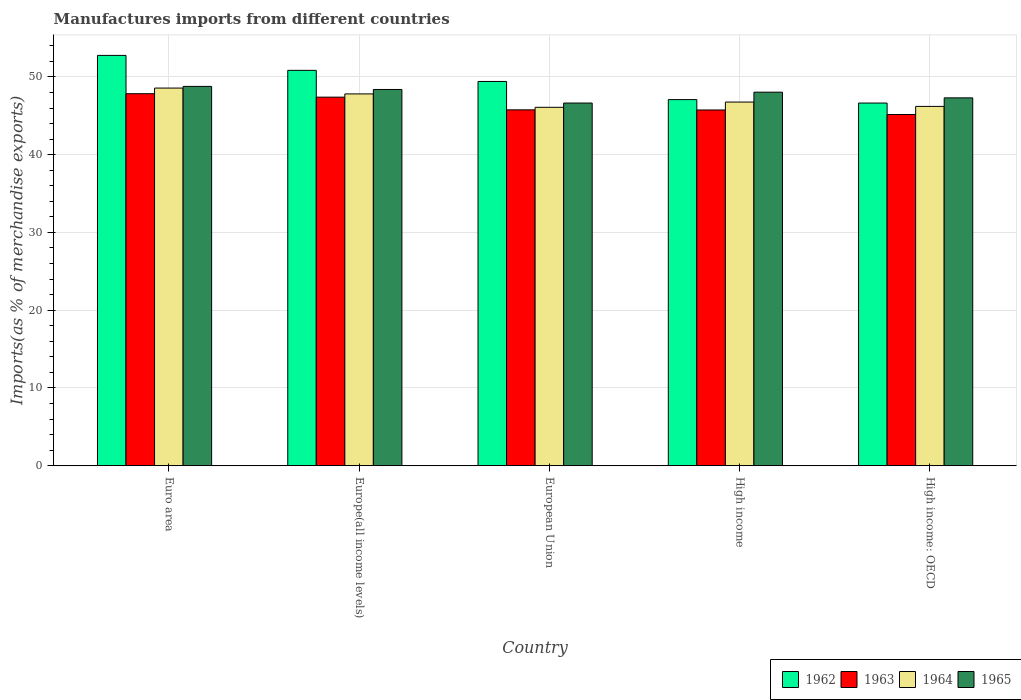How many groups of bars are there?
Your response must be concise. 5. Are the number of bars per tick equal to the number of legend labels?
Provide a short and direct response. Yes. Are the number of bars on each tick of the X-axis equal?
Offer a very short reply. Yes. How many bars are there on the 1st tick from the left?
Your answer should be very brief. 4. How many bars are there on the 5th tick from the right?
Keep it short and to the point. 4. What is the label of the 1st group of bars from the left?
Your response must be concise. Euro area. In how many cases, is the number of bars for a given country not equal to the number of legend labels?
Make the answer very short. 0. What is the percentage of imports to different countries in 1964 in High income: OECD?
Give a very brief answer. 46.21. Across all countries, what is the maximum percentage of imports to different countries in 1965?
Provide a succinct answer. 48.78. Across all countries, what is the minimum percentage of imports to different countries in 1962?
Make the answer very short. 46.64. In which country was the percentage of imports to different countries in 1962 minimum?
Ensure brevity in your answer.  High income: OECD. What is the total percentage of imports to different countries in 1963 in the graph?
Provide a short and direct response. 231.91. What is the difference between the percentage of imports to different countries in 1963 in Euro area and that in European Union?
Provide a succinct answer. 2.08. What is the difference between the percentage of imports to different countries in 1962 in High income and the percentage of imports to different countries in 1965 in Euro area?
Provide a succinct answer. -1.7. What is the average percentage of imports to different countries in 1963 per country?
Your response must be concise. 46.38. What is the difference between the percentage of imports to different countries of/in 1963 and percentage of imports to different countries of/in 1962 in High income: OECD?
Your answer should be very brief. -1.47. What is the ratio of the percentage of imports to different countries in 1963 in Euro area to that in High income?
Your answer should be compact. 1.05. Is the difference between the percentage of imports to different countries in 1963 in Euro area and Europe(all income levels) greater than the difference between the percentage of imports to different countries in 1962 in Euro area and Europe(all income levels)?
Offer a terse response. No. What is the difference between the highest and the second highest percentage of imports to different countries in 1964?
Provide a succinct answer. 1.8. What is the difference between the highest and the lowest percentage of imports to different countries in 1964?
Keep it short and to the point. 2.47. In how many countries, is the percentage of imports to different countries in 1962 greater than the average percentage of imports to different countries in 1962 taken over all countries?
Your answer should be compact. 3. Is the sum of the percentage of imports to different countries in 1962 in Euro area and High income: OECD greater than the maximum percentage of imports to different countries in 1963 across all countries?
Make the answer very short. Yes. Is it the case that in every country, the sum of the percentage of imports to different countries in 1964 and percentage of imports to different countries in 1965 is greater than the sum of percentage of imports to different countries in 1962 and percentage of imports to different countries in 1963?
Provide a succinct answer. No. Is it the case that in every country, the sum of the percentage of imports to different countries in 1963 and percentage of imports to different countries in 1962 is greater than the percentage of imports to different countries in 1964?
Keep it short and to the point. Yes. Are all the bars in the graph horizontal?
Offer a terse response. No. What is the difference between two consecutive major ticks on the Y-axis?
Provide a short and direct response. 10. Are the values on the major ticks of Y-axis written in scientific E-notation?
Offer a very short reply. No. Does the graph contain grids?
Provide a succinct answer. Yes. How many legend labels are there?
Provide a short and direct response. 4. How are the legend labels stacked?
Your answer should be very brief. Horizontal. What is the title of the graph?
Your answer should be compact. Manufactures imports from different countries. Does "1990" appear as one of the legend labels in the graph?
Your response must be concise. No. What is the label or title of the X-axis?
Offer a terse response. Country. What is the label or title of the Y-axis?
Ensure brevity in your answer.  Imports(as % of merchandise exports). What is the Imports(as % of merchandise exports) in 1962 in Euro area?
Give a very brief answer. 52.77. What is the Imports(as % of merchandise exports) in 1963 in Euro area?
Give a very brief answer. 47.84. What is the Imports(as % of merchandise exports) in 1964 in Euro area?
Offer a very short reply. 48.56. What is the Imports(as % of merchandise exports) in 1965 in Euro area?
Your answer should be compact. 48.78. What is the Imports(as % of merchandise exports) in 1962 in Europe(all income levels)?
Offer a very short reply. 50.84. What is the Imports(as % of merchandise exports) in 1963 in Europe(all income levels)?
Provide a short and direct response. 47.4. What is the Imports(as % of merchandise exports) of 1964 in Europe(all income levels)?
Provide a succinct answer. 47.81. What is the Imports(as % of merchandise exports) in 1965 in Europe(all income levels)?
Offer a very short reply. 48.38. What is the Imports(as % of merchandise exports) of 1962 in European Union?
Provide a succinct answer. 49.41. What is the Imports(as % of merchandise exports) in 1963 in European Union?
Make the answer very short. 45.76. What is the Imports(as % of merchandise exports) of 1964 in European Union?
Ensure brevity in your answer.  46.09. What is the Imports(as % of merchandise exports) in 1965 in European Union?
Provide a succinct answer. 46.64. What is the Imports(as % of merchandise exports) in 1962 in High income?
Offer a terse response. 47.08. What is the Imports(as % of merchandise exports) in 1963 in High income?
Offer a very short reply. 45.75. What is the Imports(as % of merchandise exports) in 1964 in High income?
Your answer should be very brief. 46.77. What is the Imports(as % of merchandise exports) in 1965 in High income?
Your answer should be very brief. 48.04. What is the Imports(as % of merchandise exports) in 1962 in High income: OECD?
Provide a succinct answer. 46.64. What is the Imports(as % of merchandise exports) in 1963 in High income: OECD?
Offer a terse response. 45.16. What is the Imports(as % of merchandise exports) in 1964 in High income: OECD?
Provide a succinct answer. 46.21. What is the Imports(as % of merchandise exports) in 1965 in High income: OECD?
Give a very brief answer. 47.3. Across all countries, what is the maximum Imports(as % of merchandise exports) in 1962?
Your answer should be very brief. 52.77. Across all countries, what is the maximum Imports(as % of merchandise exports) of 1963?
Provide a short and direct response. 47.84. Across all countries, what is the maximum Imports(as % of merchandise exports) in 1964?
Offer a very short reply. 48.56. Across all countries, what is the maximum Imports(as % of merchandise exports) in 1965?
Your answer should be compact. 48.78. Across all countries, what is the minimum Imports(as % of merchandise exports) in 1962?
Offer a very short reply. 46.64. Across all countries, what is the minimum Imports(as % of merchandise exports) of 1963?
Offer a terse response. 45.16. Across all countries, what is the minimum Imports(as % of merchandise exports) of 1964?
Make the answer very short. 46.09. Across all countries, what is the minimum Imports(as % of merchandise exports) of 1965?
Make the answer very short. 46.64. What is the total Imports(as % of merchandise exports) of 1962 in the graph?
Your response must be concise. 246.74. What is the total Imports(as % of merchandise exports) of 1963 in the graph?
Provide a succinct answer. 231.91. What is the total Imports(as % of merchandise exports) of 1964 in the graph?
Give a very brief answer. 235.44. What is the total Imports(as % of merchandise exports) in 1965 in the graph?
Give a very brief answer. 239.14. What is the difference between the Imports(as % of merchandise exports) of 1962 in Euro area and that in Europe(all income levels)?
Your answer should be very brief. 1.92. What is the difference between the Imports(as % of merchandise exports) in 1963 in Euro area and that in Europe(all income levels)?
Your answer should be very brief. 0.44. What is the difference between the Imports(as % of merchandise exports) in 1964 in Euro area and that in Europe(all income levels)?
Provide a succinct answer. 0.75. What is the difference between the Imports(as % of merchandise exports) of 1965 in Euro area and that in Europe(all income levels)?
Make the answer very short. 0.4. What is the difference between the Imports(as % of merchandise exports) in 1962 in Euro area and that in European Union?
Provide a short and direct response. 3.35. What is the difference between the Imports(as % of merchandise exports) in 1963 in Euro area and that in European Union?
Provide a succinct answer. 2.08. What is the difference between the Imports(as % of merchandise exports) in 1964 in Euro area and that in European Union?
Ensure brevity in your answer.  2.47. What is the difference between the Imports(as % of merchandise exports) of 1965 in Euro area and that in European Union?
Your answer should be compact. 2.14. What is the difference between the Imports(as % of merchandise exports) of 1962 in Euro area and that in High income?
Offer a terse response. 5.69. What is the difference between the Imports(as % of merchandise exports) of 1963 in Euro area and that in High income?
Give a very brief answer. 2.09. What is the difference between the Imports(as % of merchandise exports) of 1964 in Euro area and that in High income?
Offer a terse response. 1.8. What is the difference between the Imports(as % of merchandise exports) in 1965 in Euro area and that in High income?
Ensure brevity in your answer.  0.74. What is the difference between the Imports(as % of merchandise exports) of 1962 in Euro area and that in High income: OECD?
Keep it short and to the point. 6.13. What is the difference between the Imports(as % of merchandise exports) of 1963 in Euro area and that in High income: OECD?
Provide a short and direct response. 2.67. What is the difference between the Imports(as % of merchandise exports) in 1964 in Euro area and that in High income: OECD?
Ensure brevity in your answer.  2.36. What is the difference between the Imports(as % of merchandise exports) in 1965 in Euro area and that in High income: OECD?
Offer a very short reply. 1.47. What is the difference between the Imports(as % of merchandise exports) in 1962 in Europe(all income levels) and that in European Union?
Your answer should be very brief. 1.43. What is the difference between the Imports(as % of merchandise exports) in 1963 in Europe(all income levels) and that in European Union?
Give a very brief answer. 1.63. What is the difference between the Imports(as % of merchandise exports) of 1964 in Europe(all income levels) and that in European Union?
Provide a succinct answer. 1.72. What is the difference between the Imports(as % of merchandise exports) of 1965 in Europe(all income levels) and that in European Union?
Your answer should be very brief. 1.74. What is the difference between the Imports(as % of merchandise exports) of 1962 in Europe(all income levels) and that in High income?
Offer a very short reply. 3.76. What is the difference between the Imports(as % of merchandise exports) in 1963 in Europe(all income levels) and that in High income?
Your response must be concise. 1.65. What is the difference between the Imports(as % of merchandise exports) in 1964 in Europe(all income levels) and that in High income?
Your answer should be compact. 1.05. What is the difference between the Imports(as % of merchandise exports) in 1965 in Europe(all income levels) and that in High income?
Your answer should be very brief. 0.35. What is the difference between the Imports(as % of merchandise exports) in 1962 in Europe(all income levels) and that in High income: OECD?
Provide a succinct answer. 4.21. What is the difference between the Imports(as % of merchandise exports) of 1963 in Europe(all income levels) and that in High income: OECD?
Your response must be concise. 2.23. What is the difference between the Imports(as % of merchandise exports) of 1964 in Europe(all income levels) and that in High income: OECD?
Give a very brief answer. 1.61. What is the difference between the Imports(as % of merchandise exports) of 1965 in Europe(all income levels) and that in High income: OECD?
Provide a short and direct response. 1.08. What is the difference between the Imports(as % of merchandise exports) of 1962 in European Union and that in High income?
Give a very brief answer. 2.33. What is the difference between the Imports(as % of merchandise exports) in 1963 in European Union and that in High income?
Keep it short and to the point. 0.02. What is the difference between the Imports(as % of merchandise exports) in 1964 in European Union and that in High income?
Give a very brief answer. -0.68. What is the difference between the Imports(as % of merchandise exports) of 1965 in European Union and that in High income?
Your answer should be very brief. -1.4. What is the difference between the Imports(as % of merchandise exports) of 1962 in European Union and that in High income: OECD?
Ensure brevity in your answer.  2.78. What is the difference between the Imports(as % of merchandise exports) in 1963 in European Union and that in High income: OECD?
Keep it short and to the point. 0.6. What is the difference between the Imports(as % of merchandise exports) of 1964 in European Union and that in High income: OECD?
Give a very brief answer. -0.12. What is the difference between the Imports(as % of merchandise exports) of 1965 in European Union and that in High income: OECD?
Ensure brevity in your answer.  -0.67. What is the difference between the Imports(as % of merchandise exports) of 1962 in High income and that in High income: OECD?
Your response must be concise. 0.44. What is the difference between the Imports(as % of merchandise exports) of 1963 in High income and that in High income: OECD?
Offer a terse response. 0.58. What is the difference between the Imports(as % of merchandise exports) of 1964 in High income and that in High income: OECD?
Provide a succinct answer. 0.56. What is the difference between the Imports(as % of merchandise exports) of 1965 in High income and that in High income: OECD?
Make the answer very short. 0.73. What is the difference between the Imports(as % of merchandise exports) in 1962 in Euro area and the Imports(as % of merchandise exports) in 1963 in Europe(all income levels)?
Offer a terse response. 5.37. What is the difference between the Imports(as % of merchandise exports) in 1962 in Euro area and the Imports(as % of merchandise exports) in 1964 in Europe(all income levels)?
Ensure brevity in your answer.  4.95. What is the difference between the Imports(as % of merchandise exports) of 1962 in Euro area and the Imports(as % of merchandise exports) of 1965 in Europe(all income levels)?
Offer a terse response. 4.38. What is the difference between the Imports(as % of merchandise exports) in 1963 in Euro area and the Imports(as % of merchandise exports) in 1964 in Europe(all income levels)?
Offer a very short reply. 0.02. What is the difference between the Imports(as % of merchandise exports) of 1963 in Euro area and the Imports(as % of merchandise exports) of 1965 in Europe(all income levels)?
Provide a short and direct response. -0.54. What is the difference between the Imports(as % of merchandise exports) in 1964 in Euro area and the Imports(as % of merchandise exports) in 1965 in Europe(all income levels)?
Provide a succinct answer. 0.18. What is the difference between the Imports(as % of merchandise exports) of 1962 in Euro area and the Imports(as % of merchandise exports) of 1963 in European Union?
Your response must be concise. 7. What is the difference between the Imports(as % of merchandise exports) in 1962 in Euro area and the Imports(as % of merchandise exports) in 1964 in European Union?
Give a very brief answer. 6.68. What is the difference between the Imports(as % of merchandise exports) in 1962 in Euro area and the Imports(as % of merchandise exports) in 1965 in European Union?
Your answer should be compact. 6.13. What is the difference between the Imports(as % of merchandise exports) in 1963 in Euro area and the Imports(as % of merchandise exports) in 1964 in European Union?
Your response must be concise. 1.75. What is the difference between the Imports(as % of merchandise exports) in 1963 in Euro area and the Imports(as % of merchandise exports) in 1965 in European Union?
Offer a very short reply. 1.2. What is the difference between the Imports(as % of merchandise exports) in 1964 in Euro area and the Imports(as % of merchandise exports) in 1965 in European Union?
Give a very brief answer. 1.93. What is the difference between the Imports(as % of merchandise exports) of 1962 in Euro area and the Imports(as % of merchandise exports) of 1963 in High income?
Offer a very short reply. 7.02. What is the difference between the Imports(as % of merchandise exports) of 1962 in Euro area and the Imports(as % of merchandise exports) of 1964 in High income?
Ensure brevity in your answer.  6. What is the difference between the Imports(as % of merchandise exports) in 1962 in Euro area and the Imports(as % of merchandise exports) in 1965 in High income?
Keep it short and to the point. 4.73. What is the difference between the Imports(as % of merchandise exports) in 1963 in Euro area and the Imports(as % of merchandise exports) in 1964 in High income?
Offer a very short reply. 1.07. What is the difference between the Imports(as % of merchandise exports) of 1963 in Euro area and the Imports(as % of merchandise exports) of 1965 in High income?
Offer a very short reply. -0.2. What is the difference between the Imports(as % of merchandise exports) of 1964 in Euro area and the Imports(as % of merchandise exports) of 1965 in High income?
Your answer should be compact. 0.53. What is the difference between the Imports(as % of merchandise exports) of 1962 in Euro area and the Imports(as % of merchandise exports) of 1963 in High income: OECD?
Keep it short and to the point. 7.6. What is the difference between the Imports(as % of merchandise exports) of 1962 in Euro area and the Imports(as % of merchandise exports) of 1964 in High income: OECD?
Offer a very short reply. 6.56. What is the difference between the Imports(as % of merchandise exports) in 1962 in Euro area and the Imports(as % of merchandise exports) in 1965 in High income: OECD?
Offer a very short reply. 5.46. What is the difference between the Imports(as % of merchandise exports) in 1963 in Euro area and the Imports(as % of merchandise exports) in 1964 in High income: OECD?
Your response must be concise. 1.63. What is the difference between the Imports(as % of merchandise exports) in 1963 in Euro area and the Imports(as % of merchandise exports) in 1965 in High income: OECD?
Keep it short and to the point. 0.53. What is the difference between the Imports(as % of merchandise exports) of 1964 in Euro area and the Imports(as % of merchandise exports) of 1965 in High income: OECD?
Provide a succinct answer. 1.26. What is the difference between the Imports(as % of merchandise exports) in 1962 in Europe(all income levels) and the Imports(as % of merchandise exports) in 1963 in European Union?
Your response must be concise. 5.08. What is the difference between the Imports(as % of merchandise exports) of 1962 in Europe(all income levels) and the Imports(as % of merchandise exports) of 1964 in European Union?
Your answer should be compact. 4.75. What is the difference between the Imports(as % of merchandise exports) in 1962 in Europe(all income levels) and the Imports(as % of merchandise exports) in 1965 in European Union?
Provide a short and direct response. 4.2. What is the difference between the Imports(as % of merchandise exports) in 1963 in Europe(all income levels) and the Imports(as % of merchandise exports) in 1964 in European Union?
Provide a succinct answer. 1.31. What is the difference between the Imports(as % of merchandise exports) of 1963 in Europe(all income levels) and the Imports(as % of merchandise exports) of 1965 in European Union?
Your response must be concise. 0.76. What is the difference between the Imports(as % of merchandise exports) of 1964 in Europe(all income levels) and the Imports(as % of merchandise exports) of 1965 in European Union?
Provide a short and direct response. 1.18. What is the difference between the Imports(as % of merchandise exports) in 1962 in Europe(all income levels) and the Imports(as % of merchandise exports) in 1963 in High income?
Make the answer very short. 5.1. What is the difference between the Imports(as % of merchandise exports) in 1962 in Europe(all income levels) and the Imports(as % of merchandise exports) in 1964 in High income?
Give a very brief answer. 4.08. What is the difference between the Imports(as % of merchandise exports) in 1962 in Europe(all income levels) and the Imports(as % of merchandise exports) in 1965 in High income?
Provide a succinct answer. 2.81. What is the difference between the Imports(as % of merchandise exports) in 1963 in Europe(all income levels) and the Imports(as % of merchandise exports) in 1964 in High income?
Ensure brevity in your answer.  0.63. What is the difference between the Imports(as % of merchandise exports) in 1963 in Europe(all income levels) and the Imports(as % of merchandise exports) in 1965 in High income?
Your answer should be compact. -0.64. What is the difference between the Imports(as % of merchandise exports) in 1964 in Europe(all income levels) and the Imports(as % of merchandise exports) in 1965 in High income?
Your answer should be compact. -0.22. What is the difference between the Imports(as % of merchandise exports) of 1962 in Europe(all income levels) and the Imports(as % of merchandise exports) of 1963 in High income: OECD?
Give a very brief answer. 5.68. What is the difference between the Imports(as % of merchandise exports) in 1962 in Europe(all income levels) and the Imports(as % of merchandise exports) in 1964 in High income: OECD?
Your answer should be compact. 4.63. What is the difference between the Imports(as % of merchandise exports) in 1962 in Europe(all income levels) and the Imports(as % of merchandise exports) in 1965 in High income: OECD?
Offer a very short reply. 3.54. What is the difference between the Imports(as % of merchandise exports) of 1963 in Europe(all income levels) and the Imports(as % of merchandise exports) of 1964 in High income: OECD?
Offer a very short reply. 1.19. What is the difference between the Imports(as % of merchandise exports) in 1963 in Europe(all income levels) and the Imports(as % of merchandise exports) in 1965 in High income: OECD?
Provide a succinct answer. 0.09. What is the difference between the Imports(as % of merchandise exports) of 1964 in Europe(all income levels) and the Imports(as % of merchandise exports) of 1965 in High income: OECD?
Provide a short and direct response. 0.51. What is the difference between the Imports(as % of merchandise exports) in 1962 in European Union and the Imports(as % of merchandise exports) in 1963 in High income?
Make the answer very short. 3.67. What is the difference between the Imports(as % of merchandise exports) in 1962 in European Union and the Imports(as % of merchandise exports) in 1964 in High income?
Give a very brief answer. 2.65. What is the difference between the Imports(as % of merchandise exports) in 1962 in European Union and the Imports(as % of merchandise exports) in 1965 in High income?
Make the answer very short. 1.38. What is the difference between the Imports(as % of merchandise exports) of 1963 in European Union and the Imports(as % of merchandise exports) of 1964 in High income?
Offer a terse response. -1. What is the difference between the Imports(as % of merchandise exports) of 1963 in European Union and the Imports(as % of merchandise exports) of 1965 in High income?
Your answer should be very brief. -2.27. What is the difference between the Imports(as % of merchandise exports) of 1964 in European Union and the Imports(as % of merchandise exports) of 1965 in High income?
Make the answer very short. -1.94. What is the difference between the Imports(as % of merchandise exports) of 1962 in European Union and the Imports(as % of merchandise exports) of 1963 in High income: OECD?
Provide a short and direct response. 4.25. What is the difference between the Imports(as % of merchandise exports) of 1962 in European Union and the Imports(as % of merchandise exports) of 1964 in High income: OECD?
Give a very brief answer. 3.21. What is the difference between the Imports(as % of merchandise exports) in 1962 in European Union and the Imports(as % of merchandise exports) in 1965 in High income: OECD?
Keep it short and to the point. 2.11. What is the difference between the Imports(as % of merchandise exports) in 1963 in European Union and the Imports(as % of merchandise exports) in 1964 in High income: OECD?
Provide a short and direct response. -0.44. What is the difference between the Imports(as % of merchandise exports) of 1963 in European Union and the Imports(as % of merchandise exports) of 1965 in High income: OECD?
Ensure brevity in your answer.  -1.54. What is the difference between the Imports(as % of merchandise exports) of 1964 in European Union and the Imports(as % of merchandise exports) of 1965 in High income: OECD?
Your response must be concise. -1.21. What is the difference between the Imports(as % of merchandise exports) in 1962 in High income and the Imports(as % of merchandise exports) in 1963 in High income: OECD?
Make the answer very short. 1.92. What is the difference between the Imports(as % of merchandise exports) in 1962 in High income and the Imports(as % of merchandise exports) in 1964 in High income: OECD?
Make the answer very short. 0.87. What is the difference between the Imports(as % of merchandise exports) in 1962 in High income and the Imports(as % of merchandise exports) in 1965 in High income: OECD?
Provide a succinct answer. -0.22. What is the difference between the Imports(as % of merchandise exports) of 1963 in High income and the Imports(as % of merchandise exports) of 1964 in High income: OECD?
Offer a very short reply. -0.46. What is the difference between the Imports(as % of merchandise exports) in 1963 in High income and the Imports(as % of merchandise exports) in 1965 in High income: OECD?
Offer a very short reply. -1.56. What is the difference between the Imports(as % of merchandise exports) in 1964 in High income and the Imports(as % of merchandise exports) in 1965 in High income: OECD?
Your answer should be very brief. -0.54. What is the average Imports(as % of merchandise exports) of 1962 per country?
Your response must be concise. 49.35. What is the average Imports(as % of merchandise exports) in 1963 per country?
Give a very brief answer. 46.38. What is the average Imports(as % of merchandise exports) of 1964 per country?
Provide a succinct answer. 47.09. What is the average Imports(as % of merchandise exports) of 1965 per country?
Make the answer very short. 47.83. What is the difference between the Imports(as % of merchandise exports) of 1962 and Imports(as % of merchandise exports) of 1963 in Euro area?
Provide a short and direct response. 4.93. What is the difference between the Imports(as % of merchandise exports) in 1962 and Imports(as % of merchandise exports) in 1964 in Euro area?
Provide a short and direct response. 4.2. What is the difference between the Imports(as % of merchandise exports) in 1962 and Imports(as % of merchandise exports) in 1965 in Euro area?
Your answer should be very brief. 3.99. What is the difference between the Imports(as % of merchandise exports) of 1963 and Imports(as % of merchandise exports) of 1964 in Euro area?
Your response must be concise. -0.73. What is the difference between the Imports(as % of merchandise exports) of 1963 and Imports(as % of merchandise exports) of 1965 in Euro area?
Give a very brief answer. -0.94. What is the difference between the Imports(as % of merchandise exports) of 1964 and Imports(as % of merchandise exports) of 1965 in Euro area?
Provide a short and direct response. -0.21. What is the difference between the Imports(as % of merchandise exports) of 1962 and Imports(as % of merchandise exports) of 1963 in Europe(all income levels)?
Offer a very short reply. 3.45. What is the difference between the Imports(as % of merchandise exports) in 1962 and Imports(as % of merchandise exports) in 1964 in Europe(all income levels)?
Ensure brevity in your answer.  3.03. What is the difference between the Imports(as % of merchandise exports) in 1962 and Imports(as % of merchandise exports) in 1965 in Europe(all income levels)?
Make the answer very short. 2.46. What is the difference between the Imports(as % of merchandise exports) in 1963 and Imports(as % of merchandise exports) in 1964 in Europe(all income levels)?
Your answer should be compact. -0.42. What is the difference between the Imports(as % of merchandise exports) in 1963 and Imports(as % of merchandise exports) in 1965 in Europe(all income levels)?
Keep it short and to the point. -0.99. What is the difference between the Imports(as % of merchandise exports) in 1964 and Imports(as % of merchandise exports) in 1965 in Europe(all income levels)?
Offer a very short reply. -0.57. What is the difference between the Imports(as % of merchandise exports) of 1962 and Imports(as % of merchandise exports) of 1963 in European Union?
Keep it short and to the point. 3.65. What is the difference between the Imports(as % of merchandise exports) of 1962 and Imports(as % of merchandise exports) of 1964 in European Union?
Provide a short and direct response. 3.32. What is the difference between the Imports(as % of merchandise exports) in 1962 and Imports(as % of merchandise exports) in 1965 in European Union?
Make the answer very short. 2.78. What is the difference between the Imports(as % of merchandise exports) of 1963 and Imports(as % of merchandise exports) of 1964 in European Union?
Provide a succinct answer. -0.33. What is the difference between the Imports(as % of merchandise exports) of 1963 and Imports(as % of merchandise exports) of 1965 in European Union?
Offer a terse response. -0.88. What is the difference between the Imports(as % of merchandise exports) in 1964 and Imports(as % of merchandise exports) in 1965 in European Union?
Provide a short and direct response. -0.55. What is the difference between the Imports(as % of merchandise exports) in 1962 and Imports(as % of merchandise exports) in 1963 in High income?
Ensure brevity in your answer.  1.33. What is the difference between the Imports(as % of merchandise exports) of 1962 and Imports(as % of merchandise exports) of 1964 in High income?
Offer a terse response. 0.31. What is the difference between the Imports(as % of merchandise exports) of 1962 and Imports(as % of merchandise exports) of 1965 in High income?
Offer a very short reply. -0.96. What is the difference between the Imports(as % of merchandise exports) in 1963 and Imports(as % of merchandise exports) in 1964 in High income?
Your response must be concise. -1.02. What is the difference between the Imports(as % of merchandise exports) in 1963 and Imports(as % of merchandise exports) in 1965 in High income?
Your response must be concise. -2.29. What is the difference between the Imports(as % of merchandise exports) in 1964 and Imports(as % of merchandise exports) in 1965 in High income?
Make the answer very short. -1.27. What is the difference between the Imports(as % of merchandise exports) of 1962 and Imports(as % of merchandise exports) of 1963 in High income: OECD?
Keep it short and to the point. 1.47. What is the difference between the Imports(as % of merchandise exports) of 1962 and Imports(as % of merchandise exports) of 1964 in High income: OECD?
Your response must be concise. 0.43. What is the difference between the Imports(as % of merchandise exports) in 1962 and Imports(as % of merchandise exports) in 1965 in High income: OECD?
Make the answer very short. -0.67. What is the difference between the Imports(as % of merchandise exports) in 1963 and Imports(as % of merchandise exports) in 1964 in High income: OECD?
Provide a succinct answer. -1.04. What is the difference between the Imports(as % of merchandise exports) of 1963 and Imports(as % of merchandise exports) of 1965 in High income: OECD?
Give a very brief answer. -2.14. What is the difference between the Imports(as % of merchandise exports) of 1964 and Imports(as % of merchandise exports) of 1965 in High income: OECD?
Provide a succinct answer. -1.1. What is the ratio of the Imports(as % of merchandise exports) of 1962 in Euro area to that in Europe(all income levels)?
Offer a terse response. 1.04. What is the ratio of the Imports(as % of merchandise exports) in 1963 in Euro area to that in Europe(all income levels)?
Provide a succinct answer. 1.01. What is the ratio of the Imports(as % of merchandise exports) in 1964 in Euro area to that in Europe(all income levels)?
Your answer should be very brief. 1.02. What is the ratio of the Imports(as % of merchandise exports) of 1965 in Euro area to that in Europe(all income levels)?
Your response must be concise. 1.01. What is the ratio of the Imports(as % of merchandise exports) in 1962 in Euro area to that in European Union?
Keep it short and to the point. 1.07. What is the ratio of the Imports(as % of merchandise exports) in 1963 in Euro area to that in European Union?
Your answer should be compact. 1.05. What is the ratio of the Imports(as % of merchandise exports) of 1964 in Euro area to that in European Union?
Your answer should be very brief. 1.05. What is the ratio of the Imports(as % of merchandise exports) of 1965 in Euro area to that in European Union?
Make the answer very short. 1.05. What is the ratio of the Imports(as % of merchandise exports) in 1962 in Euro area to that in High income?
Keep it short and to the point. 1.12. What is the ratio of the Imports(as % of merchandise exports) of 1963 in Euro area to that in High income?
Keep it short and to the point. 1.05. What is the ratio of the Imports(as % of merchandise exports) in 1964 in Euro area to that in High income?
Your response must be concise. 1.04. What is the ratio of the Imports(as % of merchandise exports) in 1965 in Euro area to that in High income?
Give a very brief answer. 1.02. What is the ratio of the Imports(as % of merchandise exports) of 1962 in Euro area to that in High income: OECD?
Your answer should be compact. 1.13. What is the ratio of the Imports(as % of merchandise exports) in 1963 in Euro area to that in High income: OECD?
Offer a very short reply. 1.06. What is the ratio of the Imports(as % of merchandise exports) of 1964 in Euro area to that in High income: OECD?
Keep it short and to the point. 1.05. What is the ratio of the Imports(as % of merchandise exports) of 1965 in Euro area to that in High income: OECD?
Provide a succinct answer. 1.03. What is the ratio of the Imports(as % of merchandise exports) of 1962 in Europe(all income levels) to that in European Union?
Offer a very short reply. 1.03. What is the ratio of the Imports(as % of merchandise exports) of 1963 in Europe(all income levels) to that in European Union?
Ensure brevity in your answer.  1.04. What is the ratio of the Imports(as % of merchandise exports) in 1964 in Europe(all income levels) to that in European Union?
Provide a short and direct response. 1.04. What is the ratio of the Imports(as % of merchandise exports) of 1965 in Europe(all income levels) to that in European Union?
Your answer should be compact. 1.04. What is the ratio of the Imports(as % of merchandise exports) in 1962 in Europe(all income levels) to that in High income?
Make the answer very short. 1.08. What is the ratio of the Imports(as % of merchandise exports) of 1963 in Europe(all income levels) to that in High income?
Make the answer very short. 1.04. What is the ratio of the Imports(as % of merchandise exports) of 1964 in Europe(all income levels) to that in High income?
Your response must be concise. 1.02. What is the ratio of the Imports(as % of merchandise exports) in 1962 in Europe(all income levels) to that in High income: OECD?
Provide a succinct answer. 1.09. What is the ratio of the Imports(as % of merchandise exports) in 1963 in Europe(all income levels) to that in High income: OECD?
Offer a terse response. 1.05. What is the ratio of the Imports(as % of merchandise exports) of 1964 in Europe(all income levels) to that in High income: OECD?
Keep it short and to the point. 1.03. What is the ratio of the Imports(as % of merchandise exports) of 1965 in Europe(all income levels) to that in High income: OECD?
Provide a succinct answer. 1.02. What is the ratio of the Imports(as % of merchandise exports) of 1962 in European Union to that in High income?
Your answer should be very brief. 1.05. What is the ratio of the Imports(as % of merchandise exports) of 1964 in European Union to that in High income?
Offer a very short reply. 0.99. What is the ratio of the Imports(as % of merchandise exports) of 1965 in European Union to that in High income?
Give a very brief answer. 0.97. What is the ratio of the Imports(as % of merchandise exports) of 1962 in European Union to that in High income: OECD?
Offer a very short reply. 1.06. What is the ratio of the Imports(as % of merchandise exports) in 1963 in European Union to that in High income: OECD?
Provide a succinct answer. 1.01. What is the ratio of the Imports(as % of merchandise exports) in 1965 in European Union to that in High income: OECD?
Keep it short and to the point. 0.99. What is the ratio of the Imports(as % of merchandise exports) in 1962 in High income to that in High income: OECD?
Provide a short and direct response. 1.01. What is the ratio of the Imports(as % of merchandise exports) in 1963 in High income to that in High income: OECD?
Make the answer very short. 1.01. What is the ratio of the Imports(as % of merchandise exports) of 1964 in High income to that in High income: OECD?
Offer a very short reply. 1.01. What is the ratio of the Imports(as % of merchandise exports) of 1965 in High income to that in High income: OECD?
Your answer should be compact. 1.02. What is the difference between the highest and the second highest Imports(as % of merchandise exports) of 1962?
Provide a succinct answer. 1.92. What is the difference between the highest and the second highest Imports(as % of merchandise exports) in 1963?
Offer a terse response. 0.44. What is the difference between the highest and the second highest Imports(as % of merchandise exports) in 1965?
Your response must be concise. 0.4. What is the difference between the highest and the lowest Imports(as % of merchandise exports) in 1962?
Your answer should be compact. 6.13. What is the difference between the highest and the lowest Imports(as % of merchandise exports) in 1963?
Provide a short and direct response. 2.67. What is the difference between the highest and the lowest Imports(as % of merchandise exports) in 1964?
Provide a short and direct response. 2.47. What is the difference between the highest and the lowest Imports(as % of merchandise exports) of 1965?
Your answer should be very brief. 2.14. 